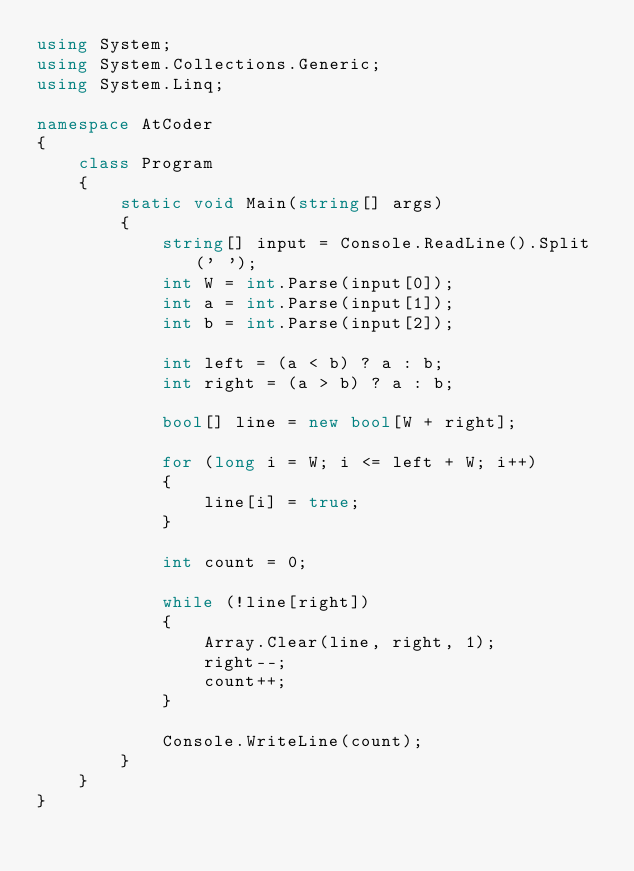<code> <loc_0><loc_0><loc_500><loc_500><_C#_>using System;
using System.Collections.Generic;
using System.Linq;

namespace AtCoder
{
    class Program
    {
        static void Main(string[] args)
        {
            string[] input = Console.ReadLine().Split(' ');
            int W = int.Parse(input[0]);
            int a = int.Parse(input[1]);
            int b = int.Parse(input[2]);

            int left = (a < b) ? a : b;
            int right = (a > b) ? a : b;

            bool[] line = new bool[W + right];

            for (long i = W; i <= left + W; i++)
            {
                line[i] = true;
            }

            int count = 0;

            while (!line[right])
            {
                Array.Clear(line, right, 1);
                right--;
                count++;
            }

            Console.WriteLine(count);
        }
    }
}
</code> 